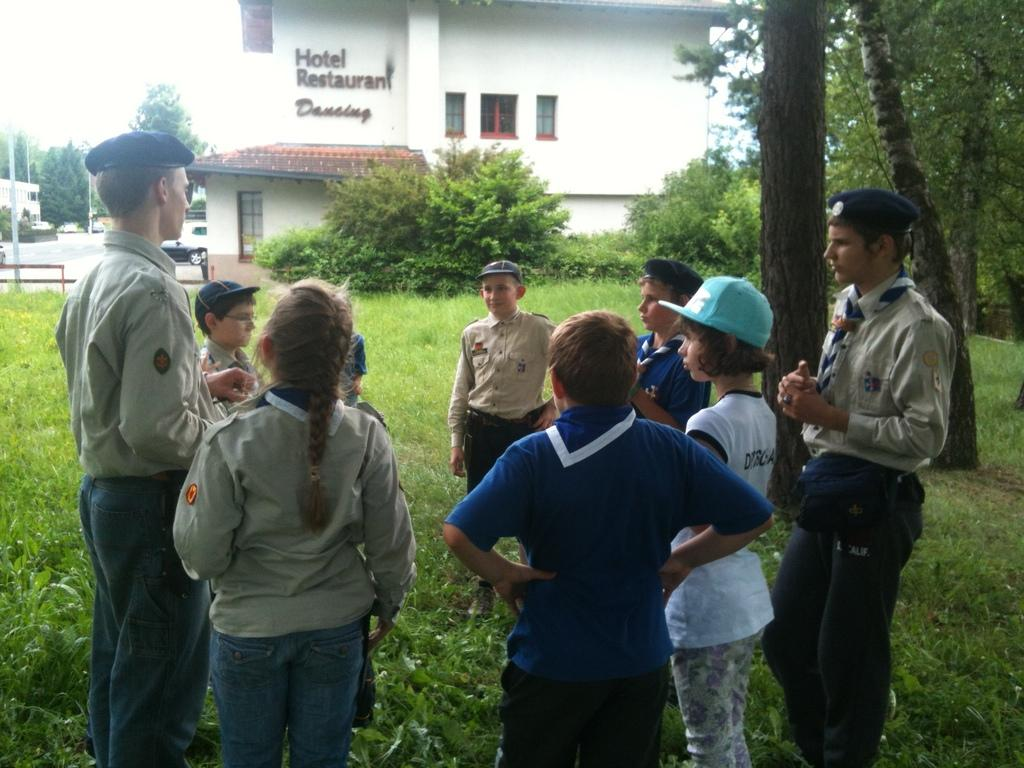What are the people in the image standing on? The people in the image are standing on the grass. What type of vegetation is visible in the image? The grass is visible in the image. What can be seen in the background of the image? There is a building and trees in the background of the image. What type of bone can be seen in the people holding in the image? There is no bone present in the image; people are standing on the grass. How old is the baby in the image? There is no baby present in the image; it features people standing on the grass. 